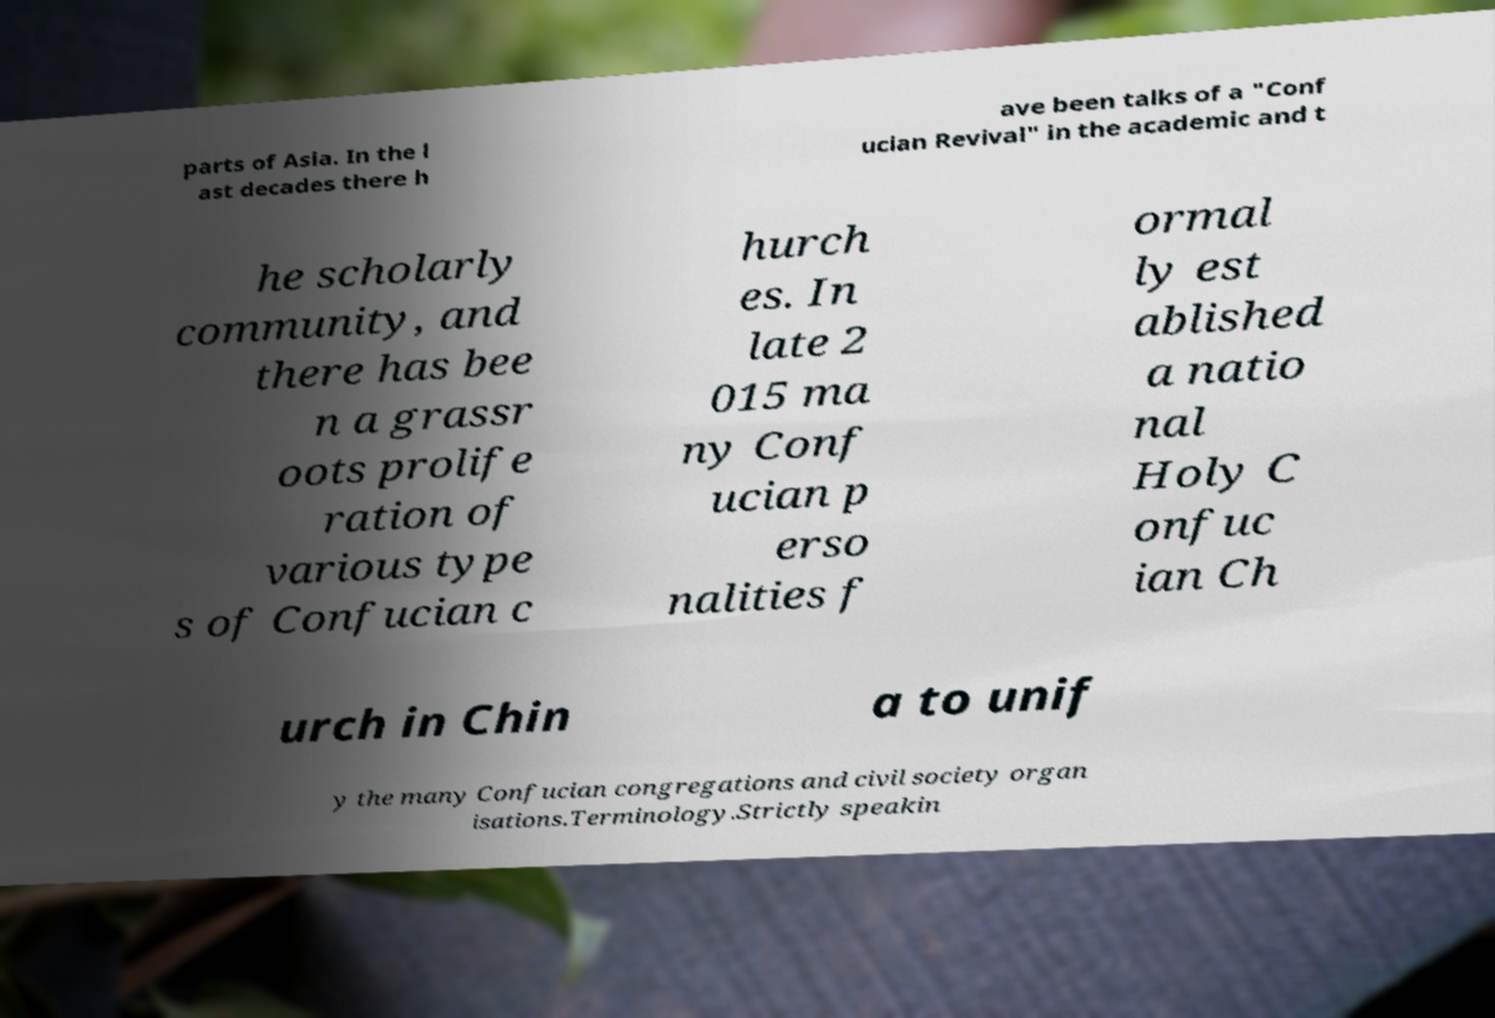Please identify and transcribe the text found in this image. parts of Asia. In the l ast decades there h ave been talks of a "Conf ucian Revival" in the academic and t he scholarly community, and there has bee n a grassr oots prolife ration of various type s of Confucian c hurch es. In late 2 015 ma ny Conf ucian p erso nalities f ormal ly est ablished a natio nal Holy C onfuc ian Ch urch in Chin a to unif y the many Confucian congregations and civil society organ isations.Terminology.Strictly speakin 